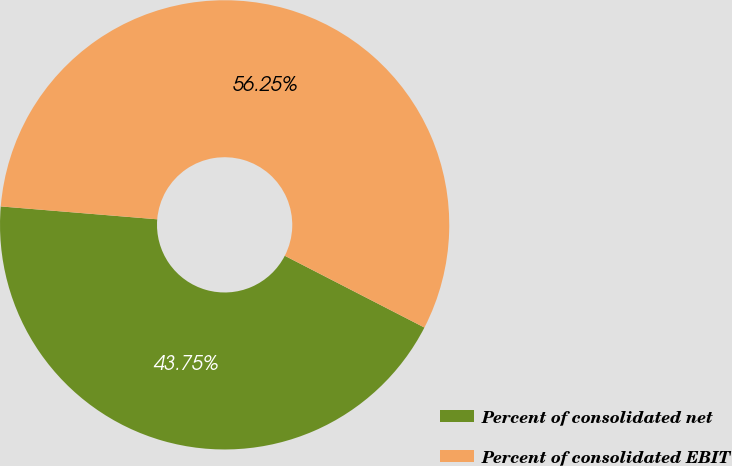Convert chart. <chart><loc_0><loc_0><loc_500><loc_500><pie_chart><fcel>Percent of consolidated net<fcel>Percent of consolidated EBIT<nl><fcel>43.75%<fcel>56.25%<nl></chart> 